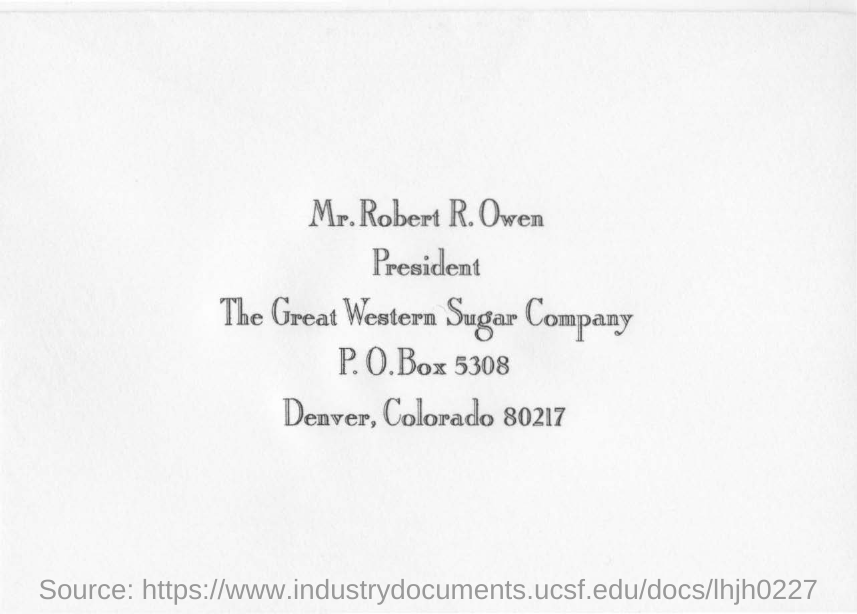Highlight a few significant elements in this photo. The P.O. Box number in the document is 5308. The location of the Great Western Sugar Company is Deaver, Colorado. 